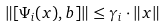Convert formula to latex. <formula><loc_0><loc_0><loc_500><loc_500>\| [ \Psi _ { i } ( x ) , b ] \| \leq \gamma _ { i } \cdot \| x \|</formula> 